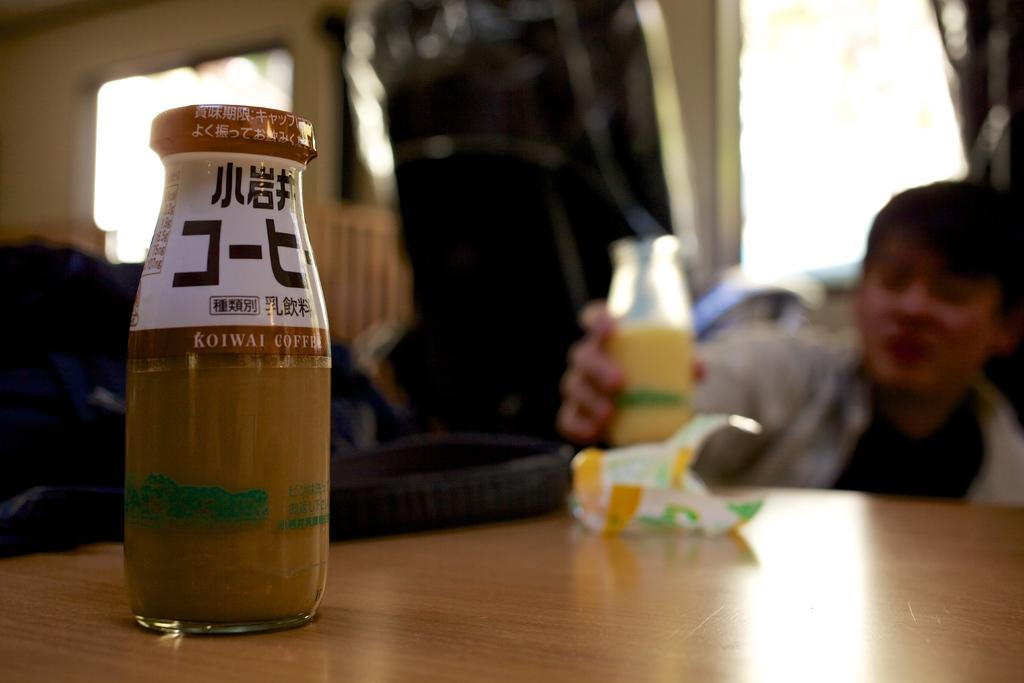How many bottles can be seen in the image? There are two bottles in the image. What is the person in the image doing with one of the bottles? A person is holding one of the bottles. Can you see a person sneezing while holding a cover in the image? There is no person sneezing or holding a cover in the image; it only features two bottles and a person holding one of them. 